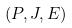Convert formula to latex. <formula><loc_0><loc_0><loc_500><loc_500>( P , J , E )</formula> 